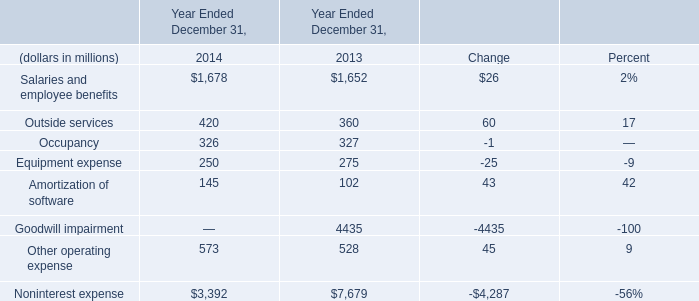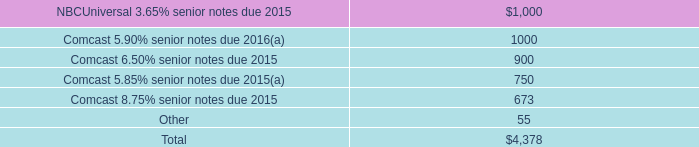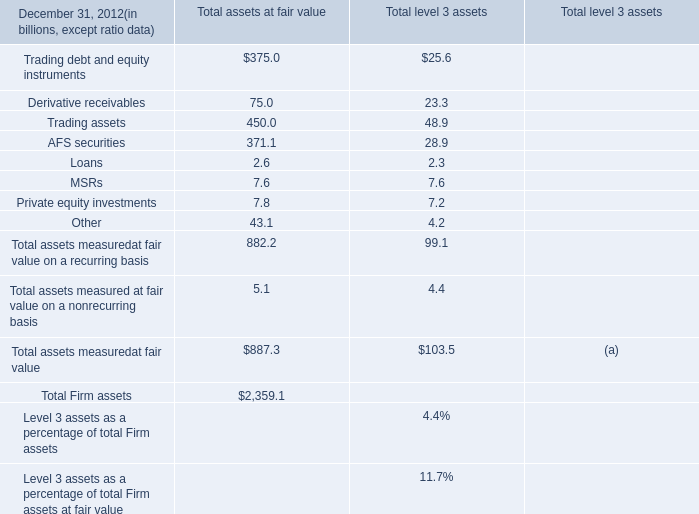In which year the sum of Other operating expense has the highest value? 
Answer: 2014. 